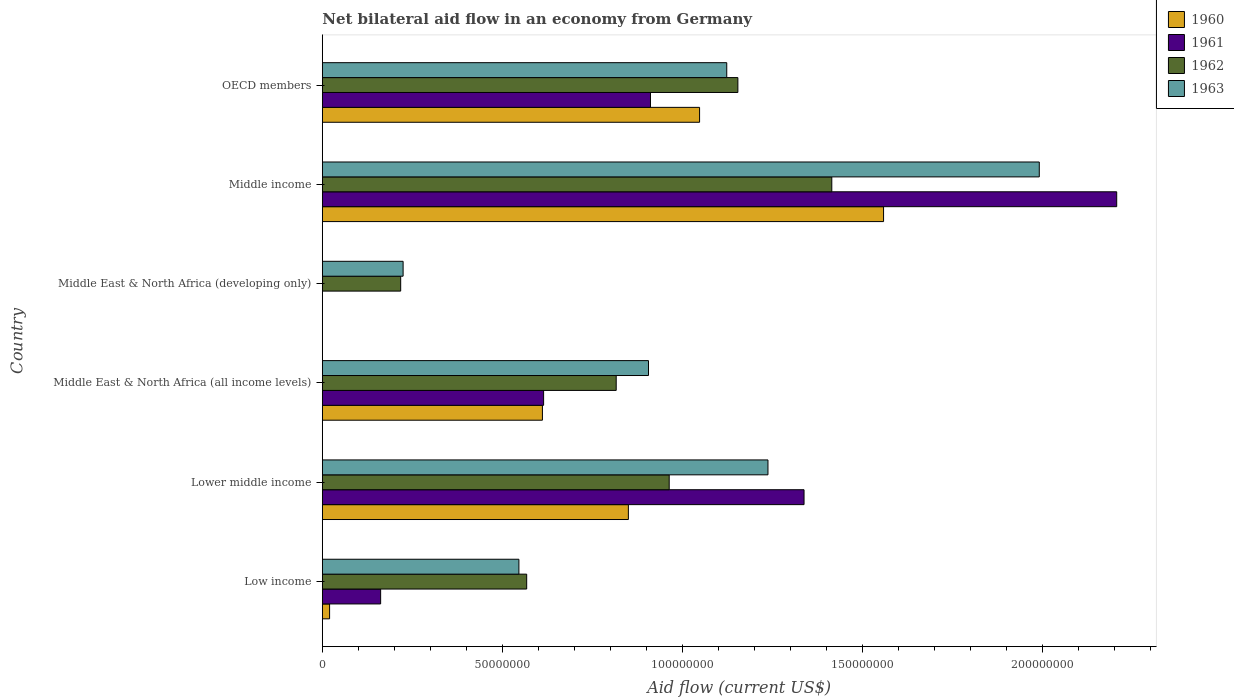How many bars are there on the 3rd tick from the top?
Make the answer very short. 2. What is the label of the 4th group of bars from the top?
Provide a succinct answer. Middle East & North Africa (all income levels). What is the net bilateral aid flow in 1962 in Middle East & North Africa (all income levels)?
Provide a short and direct response. 8.16e+07. Across all countries, what is the maximum net bilateral aid flow in 1963?
Make the answer very short. 1.99e+08. What is the total net bilateral aid flow in 1963 in the graph?
Give a very brief answer. 6.03e+08. What is the difference between the net bilateral aid flow in 1963 in Middle East & North Africa (all income levels) and that in OECD members?
Your response must be concise. -2.17e+07. What is the difference between the net bilateral aid flow in 1961 in Lower middle income and the net bilateral aid flow in 1962 in Middle income?
Your answer should be very brief. -7.71e+06. What is the average net bilateral aid flow in 1960 per country?
Provide a succinct answer. 6.81e+07. What is the difference between the net bilateral aid flow in 1962 and net bilateral aid flow in 1961 in Low income?
Provide a succinct answer. 4.06e+07. What is the ratio of the net bilateral aid flow in 1962 in Lower middle income to that in Middle East & North Africa (all income levels)?
Provide a succinct answer. 1.18. Is the net bilateral aid flow in 1961 in Middle East & North Africa (all income levels) less than that in Middle income?
Ensure brevity in your answer.  Yes. Is the difference between the net bilateral aid flow in 1962 in Middle income and OECD members greater than the difference between the net bilateral aid flow in 1961 in Middle income and OECD members?
Offer a very short reply. No. What is the difference between the highest and the second highest net bilateral aid flow in 1961?
Provide a short and direct response. 8.69e+07. What is the difference between the highest and the lowest net bilateral aid flow in 1960?
Give a very brief answer. 1.56e+08. In how many countries, is the net bilateral aid flow in 1960 greater than the average net bilateral aid flow in 1960 taken over all countries?
Your answer should be very brief. 3. Is the sum of the net bilateral aid flow in 1963 in Low income and Middle East & North Africa (all income levels) greater than the maximum net bilateral aid flow in 1962 across all countries?
Give a very brief answer. Yes. Is it the case that in every country, the sum of the net bilateral aid flow in 1961 and net bilateral aid flow in 1963 is greater than the sum of net bilateral aid flow in 1962 and net bilateral aid flow in 1960?
Keep it short and to the point. No. Is it the case that in every country, the sum of the net bilateral aid flow in 1962 and net bilateral aid flow in 1960 is greater than the net bilateral aid flow in 1961?
Your answer should be compact. Yes. How many bars are there?
Provide a succinct answer. 22. How many legend labels are there?
Ensure brevity in your answer.  4. What is the title of the graph?
Your answer should be compact. Net bilateral aid flow in an economy from Germany. What is the label or title of the X-axis?
Your response must be concise. Aid flow (current US$). What is the label or title of the Y-axis?
Provide a succinct answer. Country. What is the Aid flow (current US$) of 1960 in Low income?
Ensure brevity in your answer.  2.02e+06. What is the Aid flow (current US$) of 1961 in Low income?
Your answer should be compact. 1.62e+07. What is the Aid flow (current US$) of 1962 in Low income?
Provide a short and direct response. 5.68e+07. What is the Aid flow (current US$) in 1963 in Low income?
Offer a very short reply. 5.46e+07. What is the Aid flow (current US$) in 1960 in Lower middle income?
Ensure brevity in your answer.  8.50e+07. What is the Aid flow (current US$) of 1961 in Lower middle income?
Offer a very short reply. 1.34e+08. What is the Aid flow (current US$) in 1962 in Lower middle income?
Your answer should be very brief. 9.64e+07. What is the Aid flow (current US$) of 1963 in Lower middle income?
Offer a terse response. 1.24e+08. What is the Aid flow (current US$) of 1960 in Middle East & North Africa (all income levels)?
Offer a very short reply. 6.11e+07. What is the Aid flow (current US$) of 1961 in Middle East & North Africa (all income levels)?
Keep it short and to the point. 6.15e+07. What is the Aid flow (current US$) of 1962 in Middle East & North Africa (all income levels)?
Provide a succinct answer. 8.16e+07. What is the Aid flow (current US$) in 1963 in Middle East & North Africa (all income levels)?
Your answer should be compact. 9.06e+07. What is the Aid flow (current US$) of 1960 in Middle East & North Africa (developing only)?
Provide a short and direct response. 0. What is the Aid flow (current US$) in 1962 in Middle East & North Africa (developing only)?
Keep it short and to the point. 2.18e+07. What is the Aid flow (current US$) in 1963 in Middle East & North Africa (developing only)?
Offer a terse response. 2.24e+07. What is the Aid flow (current US$) in 1960 in Middle income?
Your response must be concise. 1.56e+08. What is the Aid flow (current US$) of 1961 in Middle income?
Give a very brief answer. 2.21e+08. What is the Aid flow (current US$) of 1962 in Middle income?
Your answer should be compact. 1.42e+08. What is the Aid flow (current US$) of 1963 in Middle income?
Offer a very short reply. 1.99e+08. What is the Aid flow (current US$) in 1960 in OECD members?
Give a very brief answer. 1.05e+08. What is the Aid flow (current US$) in 1961 in OECD members?
Your answer should be very brief. 9.12e+07. What is the Aid flow (current US$) of 1962 in OECD members?
Offer a very short reply. 1.15e+08. What is the Aid flow (current US$) in 1963 in OECD members?
Give a very brief answer. 1.12e+08. Across all countries, what is the maximum Aid flow (current US$) in 1960?
Make the answer very short. 1.56e+08. Across all countries, what is the maximum Aid flow (current US$) in 1961?
Offer a terse response. 2.21e+08. Across all countries, what is the maximum Aid flow (current US$) in 1962?
Offer a terse response. 1.42e+08. Across all countries, what is the maximum Aid flow (current US$) of 1963?
Your answer should be very brief. 1.99e+08. Across all countries, what is the minimum Aid flow (current US$) of 1962?
Offer a terse response. 2.18e+07. Across all countries, what is the minimum Aid flow (current US$) of 1963?
Ensure brevity in your answer.  2.24e+07. What is the total Aid flow (current US$) in 1960 in the graph?
Your answer should be very brief. 4.09e+08. What is the total Aid flow (current US$) of 1961 in the graph?
Your answer should be compact. 5.23e+08. What is the total Aid flow (current US$) in 1962 in the graph?
Your response must be concise. 5.14e+08. What is the total Aid flow (current US$) of 1963 in the graph?
Provide a short and direct response. 6.03e+08. What is the difference between the Aid flow (current US$) in 1960 in Low income and that in Lower middle income?
Keep it short and to the point. -8.30e+07. What is the difference between the Aid flow (current US$) of 1961 in Low income and that in Lower middle income?
Give a very brief answer. -1.18e+08. What is the difference between the Aid flow (current US$) of 1962 in Low income and that in Lower middle income?
Your answer should be very brief. -3.96e+07. What is the difference between the Aid flow (current US$) of 1963 in Low income and that in Lower middle income?
Provide a succinct answer. -6.92e+07. What is the difference between the Aid flow (current US$) of 1960 in Low income and that in Middle East & North Africa (all income levels)?
Provide a short and direct response. -5.91e+07. What is the difference between the Aid flow (current US$) of 1961 in Low income and that in Middle East & North Africa (all income levels)?
Your response must be concise. -4.53e+07. What is the difference between the Aid flow (current US$) of 1962 in Low income and that in Middle East & North Africa (all income levels)?
Your answer should be compact. -2.49e+07. What is the difference between the Aid flow (current US$) in 1963 in Low income and that in Middle East & North Africa (all income levels)?
Give a very brief answer. -3.60e+07. What is the difference between the Aid flow (current US$) in 1962 in Low income and that in Middle East & North Africa (developing only)?
Provide a succinct answer. 3.50e+07. What is the difference between the Aid flow (current US$) in 1963 in Low income and that in Middle East & North Africa (developing only)?
Give a very brief answer. 3.22e+07. What is the difference between the Aid flow (current US$) of 1960 in Low income and that in Middle income?
Provide a short and direct response. -1.54e+08. What is the difference between the Aid flow (current US$) in 1961 in Low income and that in Middle income?
Give a very brief answer. -2.04e+08. What is the difference between the Aid flow (current US$) of 1962 in Low income and that in Middle income?
Offer a terse response. -8.48e+07. What is the difference between the Aid flow (current US$) in 1963 in Low income and that in Middle income?
Your response must be concise. -1.45e+08. What is the difference between the Aid flow (current US$) in 1960 in Low income and that in OECD members?
Offer a very short reply. -1.03e+08. What is the difference between the Aid flow (current US$) in 1961 in Low income and that in OECD members?
Provide a short and direct response. -7.50e+07. What is the difference between the Aid flow (current US$) in 1962 in Low income and that in OECD members?
Your answer should be compact. -5.87e+07. What is the difference between the Aid flow (current US$) of 1963 in Low income and that in OECD members?
Offer a very short reply. -5.77e+07. What is the difference between the Aid flow (current US$) of 1960 in Lower middle income and that in Middle East & North Africa (all income levels)?
Keep it short and to the point. 2.39e+07. What is the difference between the Aid flow (current US$) in 1961 in Lower middle income and that in Middle East & North Africa (all income levels)?
Make the answer very short. 7.24e+07. What is the difference between the Aid flow (current US$) in 1962 in Lower middle income and that in Middle East & North Africa (all income levels)?
Provide a succinct answer. 1.47e+07. What is the difference between the Aid flow (current US$) in 1963 in Lower middle income and that in Middle East & North Africa (all income levels)?
Your answer should be very brief. 3.32e+07. What is the difference between the Aid flow (current US$) of 1962 in Lower middle income and that in Middle East & North Africa (developing only)?
Give a very brief answer. 7.46e+07. What is the difference between the Aid flow (current US$) of 1963 in Lower middle income and that in Middle East & North Africa (developing only)?
Provide a short and direct response. 1.01e+08. What is the difference between the Aid flow (current US$) in 1960 in Lower middle income and that in Middle income?
Ensure brevity in your answer.  -7.09e+07. What is the difference between the Aid flow (current US$) in 1961 in Lower middle income and that in Middle income?
Make the answer very short. -8.69e+07. What is the difference between the Aid flow (current US$) in 1962 in Lower middle income and that in Middle income?
Make the answer very short. -4.52e+07. What is the difference between the Aid flow (current US$) in 1963 in Lower middle income and that in Middle income?
Offer a terse response. -7.54e+07. What is the difference between the Aid flow (current US$) of 1960 in Lower middle income and that in OECD members?
Your answer should be compact. -1.98e+07. What is the difference between the Aid flow (current US$) in 1961 in Lower middle income and that in OECD members?
Your response must be concise. 4.27e+07. What is the difference between the Aid flow (current US$) of 1962 in Lower middle income and that in OECD members?
Offer a very short reply. -1.91e+07. What is the difference between the Aid flow (current US$) of 1963 in Lower middle income and that in OECD members?
Give a very brief answer. 1.14e+07. What is the difference between the Aid flow (current US$) in 1962 in Middle East & North Africa (all income levels) and that in Middle East & North Africa (developing only)?
Ensure brevity in your answer.  5.99e+07. What is the difference between the Aid flow (current US$) in 1963 in Middle East & North Africa (all income levels) and that in Middle East & North Africa (developing only)?
Your answer should be very brief. 6.82e+07. What is the difference between the Aid flow (current US$) in 1960 in Middle East & North Africa (all income levels) and that in Middle income?
Your answer should be very brief. -9.48e+07. What is the difference between the Aid flow (current US$) of 1961 in Middle East & North Africa (all income levels) and that in Middle income?
Keep it short and to the point. -1.59e+08. What is the difference between the Aid flow (current US$) of 1962 in Middle East & North Africa (all income levels) and that in Middle income?
Your answer should be very brief. -5.99e+07. What is the difference between the Aid flow (current US$) of 1963 in Middle East & North Africa (all income levels) and that in Middle income?
Your response must be concise. -1.09e+08. What is the difference between the Aid flow (current US$) of 1960 in Middle East & North Africa (all income levels) and that in OECD members?
Your response must be concise. -4.37e+07. What is the difference between the Aid flow (current US$) of 1961 in Middle East & North Africa (all income levels) and that in OECD members?
Offer a very short reply. -2.97e+07. What is the difference between the Aid flow (current US$) of 1962 in Middle East & North Africa (all income levels) and that in OECD members?
Ensure brevity in your answer.  -3.38e+07. What is the difference between the Aid flow (current US$) in 1963 in Middle East & North Africa (all income levels) and that in OECD members?
Give a very brief answer. -2.17e+07. What is the difference between the Aid flow (current US$) of 1962 in Middle East & North Africa (developing only) and that in Middle income?
Your answer should be very brief. -1.20e+08. What is the difference between the Aid flow (current US$) in 1963 in Middle East & North Africa (developing only) and that in Middle income?
Make the answer very short. -1.77e+08. What is the difference between the Aid flow (current US$) in 1962 in Middle East & North Africa (developing only) and that in OECD members?
Offer a very short reply. -9.37e+07. What is the difference between the Aid flow (current US$) in 1963 in Middle East & North Africa (developing only) and that in OECD members?
Your response must be concise. -8.99e+07. What is the difference between the Aid flow (current US$) in 1960 in Middle income and that in OECD members?
Keep it short and to the point. 5.11e+07. What is the difference between the Aid flow (current US$) in 1961 in Middle income and that in OECD members?
Your response must be concise. 1.30e+08. What is the difference between the Aid flow (current US$) of 1962 in Middle income and that in OECD members?
Your answer should be compact. 2.61e+07. What is the difference between the Aid flow (current US$) of 1963 in Middle income and that in OECD members?
Ensure brevity in your answer.  8.68e+07. What is the difference between the Aid flow (current US$) of 1960 in Low income and the Aid flow (current US$) of 1961 in Lower middle income?
Your answer should be very brief. -1.32e+08. What is the difference between the Aid flow (current US$) in 1960 in Low income and the Aid flow (current US$) in 1962 in Lower middle income?
Offer a very short reply. -9.43e+07. What is the difference between the Aid flow (current US$) of 1960 in Low income and the Aid flow (current US$) of 1963 in Lower middle income?
Provide a succinct answer. -1.22e+08. What is the difference between the Aid flow (current US$) in 1961 in Low income and the Aid flow (current US$) in 1962 in Lower middle income?
Your answer should be very brief. -8.02e+07. What is the difference between the Aid flow (current US$) in 1961 in Low income and the Aid flow (current US$) in 1963 in Lower middle income?
Ensure brevity in your answer.  -1.08e+08. What is the difference between the Aid flow (current US$) of 1962 in Low income and the Aid flow (current US$) of 1963 in Lower middle income?
Offer a very short reply. -6.70e+07. What is the difference between the Aid flow (current US$) of 1960 in Low income and the Aid flow (current US$) of 1961 in Middle East & North Africa (all income levels)?
Give a very brief answer. -5.94e+07. What is the difference between the Aid flow (current US$) of 1960 in Low income and the Aid flow (current US$) of 1962 in Middle East & North Africa (all income levels)?
Your answer should be compact. -7.96e+07. What is the difference between the Aid flow (current US$) of 1960 in Low income and the Aid flow (current US$) of 1963 in Middle East & North Africa (all income levels)?
Offer a very short reply. -8.86e+07. What is the difference between the Aid flow (current US$) in 1961 in Low income and the Aid flow (current US$) in 1962 in Middle East & North Africa (all income levels)?
Your answer should be very brief. -6.54e+07. What is the difference between the Aid flow (current US$) in 1961 in Low income and the Aid flow (current US$) in 1963 in Middle East & North Africa (all income levels)?
Your answer should be compact. -7.44e+07. What is the difference between the Aid flow (current US$) in 1962 in Low income and the Aid flow (current US$) in 1963 in Middle East & North Africa (all income levels)?
Ensure brevity in your answer.  -3.38e+07. What is the difference between the Aid flow (current US$) of 1960 in Low income and the Aid flow (current US$) of 1962 in Middle East & North Africa (developing only)?
Offer a very short reply. -1.98e+07. What is the difference between the Aid flow (current US$) of 1960 in Low income and the Aid flow (current US$) of 1963 in Middle East & North Africa (developing only)?
Give a very brief answer. -2.04e+07. What is the difference between the Aid flow (current US$) of 1961 in Low income and the Aid flow (current US$) of 1962 in Middle East & North Africa (developing only)?
Your answer should be very brief. -5.57e+06. What is the difference between the Aid flow (current US$) of 1961 in Low income and the Aid flow (current US$) of 1963 in Middle East & North Africa (developing only)?
Give a very brief answer. -6.24e+06. What is the difference between the Aid flow (current US$) in 1962 in Low income and the Aid flow (current US$) in 1963 in Middle East & North Africa (developing only)?
Offer a terse response. 3.43e+07. What is the difference between the Aid flow (current US$) of 1960 in Low income and the Aid flow (current US$) of 1961 in Middle income?
Your answer should be compact. -2.19e+08. What is the difference between the Aid flow (current US$) of 1960 in Low income and the Aid flow (current US$) of 1962 in Middle income?
Make the answer very short. -1.40e+08. What is the difference between the Aid flow (current US$) in 1960 in Low income and the Aid flow (current US$) in 1963 in Middle income?
Offer a very short reply. -1.97e+08. What is the difference between the Aid flow (current US$) in 1961 in Low income and the Aid flow (current US$) in 1962 in Middle income?
Your answer should be compact. -1.25e+08. What is the difference between the Aid flow (current US$) in 1961 in Low income and the Aid flow (current US$) in 1963 in Middle income?
Give a very brief answer. -1.83e+08. What is the difference between the Aid flow (current US$) in 1962 in Low income and the Aid flow (current US$) in 1963 in Middle income?
Provide a succinct answer. -1.42e+08. What is the difference between the Aid flow (current US$) in 1960 in Low income and the Aid flow (current US$) in 1961 in OECD members?
Your response must be concise. -8.91e+07. What is the difference between the Aid flow (current US$) in 1960 in Low income and the Aid flow (current US$) in 1962 in OECD members?
Ensure brevity in your answer.  -1.13e+08. What is the difference between the Aid flow (current US$) of 1960 in Low income and the Aid flow (current US$) of 1963 in OECD members?
Make the answer very short. -1.10e+08. What is the difference between the Aid flow (current US$) in 1961 in Low income and the Aid flow (current US$) in 1962 in OECD members?
Offer a very short reply. -9.92e+07. What is the difference between the Aid flow (current US$) in 1961 in Low income and the Aid flow (current US$) in 1963 in OECD members?
Provide a short and direct response. -9.62e+07. What is the difference between the Aid flow (current US$) of 1962 in Low income and the Aid flow (current US$) of 1963 in OECD members?
Give a very brief answer. -5.56e+07. What is the difference between the Aid flow (current US$) in 1960 in Lower middle income and the Aid flow (current US$) in 1961 in Middle East & North Africa (all income levels)?
Your response must be concise. 2.36e+07. What is the difference between the Aid flow (current US$) in 1960 in Lower middle income and the Aid flow (current US$) in 1962 in Middle East & North Africa (all income levels)?
Your answer should be very brief. 3.38e+06. What is the difference between the Aid flow (current US$) of 1960 in Lower middle income and the Aid flow (current US$) of 1963 in Middle East & North Africa (all income levels)?
Give a very brief answer. -5.59e+06. What is the difference between the Aid flow (current US$) in 1961 in Lower middle income and the Aid flow (current US$) in 1962 in Middle East & North Africa (all income levels)?
Offer a very short reply. 5.22e+07. What is the difference between the Aid flow (current US$) of 1961 in Lower middle income and the Aid flow (current US$) of 1963 in Middle East & North Africa (all income levels)?
Make the answer very short. 4.32e+07. What is the difference between the Aid flow (current US$) of 1962 in Lower middle income and the Aid flow (current US$) of 1963 in Middle East & North Africa (all income levels)?
Your answer should be compact. 5.75e+06. What is the difference between the Aid flow (current US$) of 1960 in Lower middle income and the Aid flow (current US$) of 1962 in Middle East & North Africa (developing only)?
Offer a very short reply. 6.32e+07. What is the difference between the Aid flow (current US$) of 1960 in Lower middle income and the Aid flow (current US$) of 1963 in Middle East & North Africa (developing only)?
Your answer should be compact. 6.26e+07. What is the difference between the Aid flow (current US$) of 1961 in Lower middle income and the Aid flow (current US$) of 1962 in Middle East & North Africa (developing only)?
Provide a succinct answer. 1.12e+08. What is the difference between the Aid flow (current US$) in 1961 in Lower middle income and the Aid flow (current US$) in 1963 in Middle East & North Africa (developing only)?
Provide a succinct answer. 1.11e+08. What is the difference between the Aid flow (current US$) of 1962 in Lower middle income and the Aid flow (current US$) of 1963 in Middle East & North Africa (developing only)?
Provide a short and direct response. 7.39e+07. What is the difference between the Aid flow (current US$) in 1960 in Lower middle income and the Aid flow (current US$) in 1961 in Middle income?
Ensure brevity in your answer.  -1.36e+08. What is the difference between the Aid flow (current US$) in 1960 in Lower middle income and the Aid flow (current US$) in 1962 in Middle income?
Offer a terse response. -5.65e+07. What is the difference between the Aid flow (current US$) of 1960 in Lower middle income and the Aid flow (current US$) of 1963 in Middle income?
Offer a very short reply. -1.14e+08. What is the difference between the Aid flow (current US$) of 1961 in Lower middle income and the Aid flow (current US$) of 1962 in Middle income?
Make the answer very short. -7.71e+06. What is the difference between the Aid flow (current US$) in 1961 in Lower middle income and the Aid flow (current US$) in 1963 in Middle income?
Provide a succinct answer. -6.54e+07. What is the difference between the Aid flow (current US$) of 1962 in Lower middle income and the Aid flow (current US$) of 1963 in Middle income?
Keep it short and to the point. -1.03e+08. What is the difference between the Aid flow (current US$) in 1960 in Lower middle income and the Aid flow (current US$) in 1961 in OECD members?
Your answer should be compact. -6.14e+06. What is the difference between the Aid flow (current US$) of 1960 in Lower middle income and the Aid flow (current US$) of 1962 in OECD members?
Your response must be concise. -3.04e+07. What is the difference between the Aid flow (current US$) of 1960 in Lower middle income and the Aid flow (current US$) of 1963 in OECD members?
Give a very brief answer. -2.73e+07. What is the difference between the Aid flow (current US$) of 1961 in Lower middle income and the Aid flow (current US$) of 1962 in OECD members?
Provide a succinct answer. 1.84e+07. What is the difference between the Aid flow (current US$) in 1961 in Lower middle income and the Aid flow (current US$) in 1963 in OECD members?
Keep it short and to the point. 2.15e+07. What is the difference between the Aid flow (current US$) of 1962 in Lower middle income and the Aid flow (current US$) of 1963 in OECD members?
Provide a succinct answer. -1.60e+07. What is the difference between the Aid flow (current US$) of 1960 in Middle East & North Africa (all income levels) and the Aid flow (current US$) of 1962 in Middle East & North Africa (developing only)?
Provide a succinct answer. 3.94e+07. What is the difference between the Aid flow (current US$) of 1960 in Middle East & North Africa (all income levels) and the Aid flow (current US$) of 1963 in Middle East & North Africa (developing only)?
Keep it short and to the point. 3.87e+07. What is the difference between the Aid flow (current US$) in 1961 in Middle East & North Africa (all income levels) and the Aid flow (current US$) in 1962 in Middle East & North Africa (developing only)?
Provide a succinct answer. 3.97e+07. What is the difference between the Aid flow (current US$) of 1961 in Middle East & North Africa (all income levels) and the Aid flow (current US$) of 1963 in Middle East & North Africa (developing only)?
Provide a succinct answer. 3.90e+07. What is the difference between the Aid flow (current US$) in 1962 in Middle East & North Africa (all income levels) and the Aid flow (current US$) in 1963 in Middle East & North Africa (developing only)?
Offer a terse response. 5.92e+07. What is the difference between the Aid flow (current US$) of 1960 in Middle East & North Africa (all income levels) and the Aid flow (current US$) of 1961 in Middle income?
Give a very brief answer. -1.60e+08. What is the difference between the Aid flow (current US$) of 1960 in Middle East & North Africa (all income levels) and the Aid flow (current US$) of 1962 in Middle income?
Offer a terse response. -8.04e+07. What is the difference between the Aid flow (current US$) in 1960 in Middle East & North Africa (all income levels) and the Aid flow (current US$) in 1963 in Middle income?
Make the answer very short. -1.38e+08. What is the difference between the Aid flow (current US$) of 1961 in Middle East & North Africa (all income levels) and the Aid flow (current US$) of 1962 in Middle income?
Make the answer very short. -8.01e+07. What is the difference between the Aid flow (current US$) of 1961 in Middle East & North Africa (all income levels) and the Aid flow (current US$) of 1963 in Middle income?
Provide a short and direct response. -1.38e+08. What is the difference between the Aid flow (current US$) of 1962 in Middle East & North Africa (all income levels) and the Aid flow (current US$) of 1963 in Middle income?
Your answer should be very brief. -1.18e+08. What is the difference between the Aid flow (current US$) in 1960 in Middle East & North Africa (all income levels) and the Aid flow (current US$) in 1961 in OECD members?
Your answer should be compact. -3.00e+07. What is the difference between the Aid flow (current US$) of 1960 in Middle East & North Africa (all income levels) and the Aid flow (current US$) of 1962 in OECD members?
Ensure brevity in your answer.  -5.43e+07. What is the difference between the Aid flow (current US$) in 1960 in Middle East & North Africa (all income levels) and the Aid flow (current US$) in 1963 in OECD members?
Give a very brief answer. -5.12e+07. What is the difference between the Aid flow (current US$) in 1961 in Middle East & North Africa (all income levels) and the Aid flow (current US$) in 1962 in OECD members?
Provide a short and direct response. -5.40e+07. What is the difference between the Aid flow (current US$) in 1961 in Middle East & North Africa (all income levels) and the Aid flow (current US$) in 1963 in OECD members?
Your response must be concise. -5.09e+07. What is the difference between the Aid flow (current US$) in 1962 in Middle East & North Africa (all income levels) and the Aid flow (current US$) in 1963 in OECD members?
Make the answer very short. -3.07e+07. What is the difference between the Aid flow (current US$) in 1962 in Middle East & North Africa (developing only) and the Aid flow (current US$) in 1963 in Middle income?
Provide a short and direct response. -1.77e+08. What is the difference between the Aid flow (current US$) of 1962 in Middle East & North Africa (developing only) and the Aid flow (current US$) of 1963 in OECD members?
Your answer should be very brief. -9.06e+07. What is the difference between the Aid flow (current US$) in 1960 in Middle income and the Aid flow (current US$) in 1961 in OECD members?
Keep it short and to the point. 6.48e+07. What is the difference between the Aid flow (current US$) of 1960 in Middle income and the Aid flow (current US$) of 1962 in OECD members?
Offer a terse response. 4.05e+07. What is the difference between the Aid flow (current US$) in 1960 in Middle income and the Aid flow (current US$) in 1963 in OECD members?
Your answer should be compact. 4.36e+07. What is the difference between the Aid flow (current US$) of 1961 in Middle income and the Aid flow (current US$) of 1962 in OECD members?
Provide a short and direct response. 1.05e+08. What is the difference between the Aid flow (current US$) of 1961 in Middle income and the Aid flow (current US$) of 1963 in OECD members?
Your response must be concise. 1.08e+08. What is the difference between the Aid flow (current US$) of 1962 in Middle income and the Aid flow (current US$) of 1963 in OECD members?
Your answer should be compact. 2.92e+07. What is the average Aid flow (current US$) in 1960 per country?
Your response must be concise. 6.81e+07. What is the average Aid flow (current US$) of 1961 per country?
Your response must be concise. 8.72e+07. What is the average Aid flow (current US$) of 1962 per country?
Offer a very short reply. 8.56e+07. What is the average Aid flow (current US$) of 1963 per country?
Your response must be concise. 1.00e+08. What is the difference between the Aid flow (current US$) of 1960 and Aid flow (current US$) of 1961 in Low income?
Offer a very short reply. -1.42e+07. What is the difference between the Aid flow (current US$) in 1960 and Aid flow (current US$) in 1962 in Low income?
Your answer should be compact. -5.48e+07. What is the difference between the Aid flow (current US$) in 1960 and Aid flow (current US$) in 1963 in Low income?
Your answer should be compact. -5.26e+07. What is the difference between the Aid flow (current US$) in 1961 and Aid flow (current US$) in 1962 in Low income?
Provide a short and direct response. -4.06e+07. What is the difference between the Aid flow (current US$) of 1961 and Aid flow (current US$) of 1963 in Low income?
Offer a terse response. -3.84e+07. What is the difference between the Aid flow (current US$) of 1962 and Aid flow (current US$) of 1963 in Low income?
Ensure brevity in your answer.  2.16e+06. What is the difference between the Aid flow (current US$) in 1960 and Aid flow (current US$) in 1961 in Lower middle income?
Offer a very short reply. -4.88e+07. What is the difference between the Aid flow (current US$) in 1960 and Aid flow (current US$) in 1962 in Lower middle income?
Your response must be concise. -1.13e+07. What is the difference between the Aid flow (current US$) of 1960 and Aid flow (current US$) of 1963 in Lower middle income?
Your answer should be very brief. -3.88e+07. What is the difference between the Aid flow (current US$) of 1961 and Aid flow (current US$) of 1962 in Lower middle income?
Your answer should be compact. 3.75e+07. What is the difference between the Aid flow (current US$) of 1961 and Aid flow (current US$) of 1963 in Lower middle income?
Ensure brevity in your answer.  1.00e+07. What is the difference between the Aid flow (current US$) in 1962 and Aid flow (current US$) in 1963 in Lower middle income?
Keep it short and to the point. -2.74e+07. What is the difference between the Aid flow (current US$) of 1960 and Aid flow (current US$) of 1961 in Middle East & North Africa (all income levels)?
Your response must be concise. -3.30e+05. What is the difference between the Aid flow (current US$) of 1960 and Aid flow (current US$) of 1962 in Middle East & North Africa (all income levels)?
Keep it short and to the point. -2.05e+07. What is the difference between the Aid flow (current US$) in 1960 and Aid flow (current US$) in 1963 in Middle East & North Africa (all income levels)?
Provide a short and direct response. -2.95e+07. What is the difference between the Aid flow (current US$) of 1961 and Aid flow (current US$) of 1962 in Middle East & North Africa (all income levels)?
Your answer should be very brief. -2.02e+07. What is the difference between the Aid flow (current US$) of 1961 and Aid flow (current US$) of 1963 in Middle East & North Africa (all income levels)?
Ensure brevity in your answer.  -2.91e+07. What is the difference between the Aid flow (current US$) of 1962 and Aid flow (current US$) of 1963 in Middle East & North Africa (all income levels)?
Ensure brevity in your answer.  -8.97e+06. What is the difference between the Aid flow (current US$) in 1962 and Aid flow (current US$) in 1963 in Middle East & North Africa (developing only)?
Make the answer very short. -6.70e+05. What is the difference between the Aid flow (current US$) in 1960 and Aid flow (current US$) in 1961 in Middle income?
Offer a terse response. -6.48e+07. What is the difference between the Aid flow (current US$) in 1960 and Aid flow (current US$) in 1962 in Middle income?
Keep it short and to the point. 1.44e+07. What is the difference between the Aid flow (current US$) in 1960 and Aid flow (current US$) in 1963 in Middle income?
Keep it short and to the point. -4.33e+07. What is the difference between the Aid flow (current US$) in 1961 and Aid flow (current US$) in 1962 in Middle income?
Your answer should be compact. 7.92e+07. What is the difference between the Aid flow (current US$) of 1961 and Aid flow (current US$) of 1963 in Middle income?
Make the answer very short. 2.15e+07. What is the difference between the Aid flow (current US$) in 1962 and Aid flow (current US$) in 1963 in Middle income?
Provide a succinct answer. -5.76e+07. What is the difference between the Aid flow (current US$) in 1960 and Aid flow (current US$) in 1961 in OECD members?
Ensure brevity in your answer.  1.36e+07. What is the difference between the Aid flow (current US$) in 1960 and Aid flow (current US$) in 1962 in OECD members?
Give a very brief answer. -1.06e+07. What is the difference between the Aid flow (current US$) in 1960 and Aid flow (current US$) in 1963 in OECD members?
Your answer should be very brief. -7.55e+06. What is the difference between the Aid flow (current US$) in 1961 and Aid flow (current US$) in 1962 in OECD members?
Offer a terse response. -2.43e+07. What is the difference between the Aid flow (current US$) in 1961 and Aid flow (current US$) in 1963 in OECD members?
Make the answer very short. -2.12e+07. What is the difference between the Aid flow (current US$) in 1962 and Aid flow (current US$) in 1963 in OECD members?
Provide a short and direct response. 3.09e+06. What is the ratio of the Aid flow (current US$) in 1960 in Low income to that in Lower middle income?
Offer a terse response. 0.02. What is the ratio of the Aid flow (current US$) in 1961 in Low income to that in Lower middle income?
Offer a very short reply. 0.12. What is the ratio of the Aid flow (current US$) of 1962 in Low income to that in Lower middle income?
Provide a short and direct response. 0.59. What is the ratio of the Aid flow (current US$) in 1963 in Low income to that in Lower middle income?
Offer a terse response. 0.44. What is the ratio of the Aid flow (current US$) of 1960 in Low income to that in Middle East & North Africa (all income levels)?
Make the answer very short. 0.03. What is the ratio of the Aid flow (current US$) of 1961 in Low income to that in Middle East & North Africa (all income levels)?
Keep it short and to the point. 0.26. What is the ratio of the Aid flow (current US$) in 1962 in Low income to that in Middle East & North Africa (all income levels)?
Your answer should be compact. 0.7. What is the ratio of the Aid flow (current US$) of 1963 in Low income to that in Middle East & North Africa (all income levels)?
Keep it short and to the point. 0.6. What is the ratio of the Aid flow (current US$) of 1962 in Low income to that in Middle East & North Africa (developing only)?
Ensure brevity in your answer.  2.61. What is the ratio of the Aid flow (current US$) of 1963 in Low income to that in Middle East & North Africa (developing only)?
Your answer should be very brief. 2.43. What is the ratio of the Aid flow (current US$) in 1960 in Low income to that in Middle income?
Make the answer very short. 0.01. What is the ratio of the Aid flow (current US$) of 1961 in Low income to that in Middle income?
Make the answer very short. 0.07. What is the ratio of the Aid flow (current US$) in 1962 in Low income to that in Middle income?
Offer a terse response. 0.4. What is the ratio of the Aid flow (current US$) in 1963 in Low income to that in Middle income?
Ensure brevity in your answer.  0.27. What is the ratio of the Aid flow (current US$) in 1960 in Low income to that in OECD members?
Offer a very short reply. 0.02. What is the ratio of the Aid flow (current US$) in 1961 in Low income to that in OECD members?
Your answer should be compact. 0.18. What is the ratio of the Aid flow (current US$) of 1962 in Low income to that in OECD members?
Provide a short and direct response. 0.49. What is the ratio of the Aid flow (current US$) in 1963 in Low income to that in OECD members?
Keep it short and to the point. 0.49. What is the ratio of the Aid flow (current US$) in 1960 in Lower middle income to that in Middle East & North Africa (all income levels)?
Keep it short and to the point. 1.39. What is the ratio of the Aid flow (current US$) of 1961 in Lower middle income to that in Middle East & North Africa (all income levels)?
Provide a succinct answer. 2.18. What is the ratio of the Aid flow (current US$) of 1962 in Lower middle income to that in Middle East & North Africa (all income levels)?
Provide a succinct answer. 1.18. What is the ratio of the Aid flow (current US$) of 1963 in Lower middle income to that in Middle East & North Africa (all income levels)?
Offer a terse response. 1.37. What is the ratio of the Aid flow (current US$) in 1962 in Lower middle income to that in Middle East & North Africa (developing only)?
Provide a succinct answer. 4.43. What is the ratio of the Aid flow (current US$) in 1963 in Lower middle income to that in Middle East & North Africa (developing only)?
Your response must be concise. 5.52. What is the ratio of the Aid flow (current US$) in 1960 in Lower middle income to that in Middle income?
Keep it short and to the point. 0.55. What is the ratio of the Aid flow (current US$) in 1961 in Lower middle income to that in Middle income?
Ensure brevity in your answer.  0.61. What is the ratio of the Aid flow (current US$) of 1962 in Lower middle income to that in Middle income?
Offer a terse response. 0.68. What is the ratio of the Aid flow (current US$) in 1963 in Lower middle income to that in Middle income?
Provide a succinct answer. 0.62. What is the ratio of the Aid flow (current US$) of 1960 in Lower middle income to that in OECD members?
Ensure brevity in your answer.  0.81. What is the ratio of the Aid flow (current US$) of 1961 in Lower middle income to that in OECD members?
Provide a succinct answer. 1.47. What is the ratio of the Aid flow (current US$) in 1962 in Lower middle income to that in OECD members?
Ensure brevity in your answer.  0.83. What is the ratio of the Aid flow (current US$) of 1963 in Lower middle income to that in OECD members?
Offer a terse response. 1.1. What is the ratio of the Aid flow (current US$) of 1962 in Middle East & North Africa (all income levels) to that in Middle East & North Africa (developing only)?
Provide a succinct answer. 3.75. What is the ratio of the Aid flow (current US$) in 1963 in Middle East & North Africa (all income levels) to that in Middle East & North Africa (developing only)?
Offer a terse response. 4.04. What is the ratio of the Aid flow (current US$) in 1960 in Middle East & North Africa (all income levels) to that in Middle income?
Make the answer very short. 0.39. What is the ratio of the Aid flow (current US$) of 1961 in Middle East & North Africa (all income levels) to that in Middle income?
Your answer should be compact. 0.28. What is the ratio of the Aid flow (current US$) in 1962 in Middle East & North Africa (all income levels) to that in Middle income?
Give a very brief answer. 0.58. What is the ratio of the Aid flow (current US$) of 1963 in Middle East & North Africa (all income levels) to that in Middle income?
Give a very brief answer. 0.45. What is the ratio of the Aid flow (current US$) in 1960 in Middle East & North Africa (all income levels) to that in OECD members?
Your answer should be compact. 0.58. What is the ratio of the Aid flow (current US$) in 1961 in Middle East & North Africa (all income levels) to that in OECD members?
Your answer should be very brief. 0.67. What is the ratio of the Aid flow (current US$) in 1962 in Middle East & North Africa (all income levels) to that in OECD members?
Offer a terse response. 0.71. What is the ratio of the Aid flow (current US$) in 1963 in Middle East & North Africa (all income levels) to that in OECD members?
Your response must be concise. 0.81. What is the ratio of the Aid flow (current US$) in 1962 in Middle East & North Africa (developing only) to that in Middle income?
Your answer should be very brief. 0.15. What is the ratio of the Aid flow (current US$) in 1963 in Middle East & North Africa (developing only) to that in Middle income?
Make the answer very short. 0.11. What is the ratio of the Aid flow (current US$) in 1962 in Middle East & North Africa (developing only) to that in OECD members?
Provide a short and direct response. 0.19. What is the ratio of the Aid flow (current US$) in 1963 in Middle East & North Africa (developing only) to that in OECD members?
Your answer should be compact. 0.2. What is the ratio of the Aid flow (current US$) in 1960 in Middle income to that in OECD members?
Make the answer very short. 1.49. What is the ratio of the Aid flow (current US$) in 1961 in Middle income to that in OECD members?
Your response must be concise. 2.42. What is the ratio of the Aid flow (current US$) in 1962 in Middle income to that in OECD members?
Your response must be concise. 1.23. What is the ratio of the Aid flow (current US$) of 1963 in Middle income to that in OECD members?
Your answer should be compact. 1.77. What is the difference between the highest and the second highest Aid flow (current US$) of 1960?
Offer a very short reply. 5.11e+07. What is the difference between the highest and the second highest Aid flow (current US$) in 1961?
Keep it short and to the point. 8.69e+07. What is the difference between the highest and the second highest Aid flow (current US$) of 1962?
Provide a short and direct response. 2.61e+07. What is the difference between the highest and the second highest Aid flow (current US$) in 1963?
Offer a very short reply. 7.54e+07. What is the difference between the highest and the lowest Aid flow (current US$) in 1960?
Your answer should be compact. 1.56e+08. What is the difference between the highest and the lowest Aid flow (current US$) of 1961?
Keep it short and to the point. 2.21e+08. What is the difference between the highest and the lowest Aid flow (current US$) of 1962?
Give a very brief answer. 1.20e+08. What is the difference between the highest and the lowest Aid flow (current US$) of 1963?
Make the answer very short. 1.77e+08. 